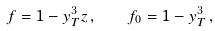Convert formula to latex. <formula><loc_0><loc_0><loc_500><loc_500>f = 1 - y _ { T } ^ { 3 } z \, , \quad f _ { 0 } = 1 - y _ { T } ^ { 3 } \, ,</formula> 